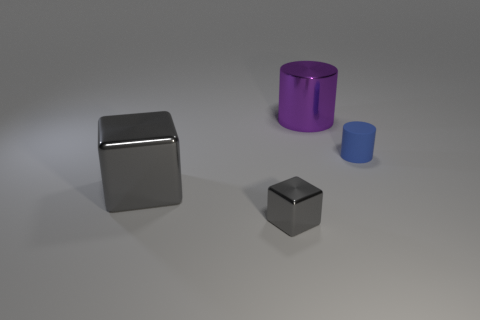There is a thing that is both behind the large gray metal block and to the left of the small blue rubber object; what is it made of?
Keep it short and to the point. Metal. Are there fewer blue rubber things on the left side of the small gray metal object than metallic cylinders that are in front of the tiny blue rubber cylinder?
Provide a succinct answer. No. What number of other objects are the same size as the blue cylinder?
Offer a terse response. 1. There is a big shiny object in front of the large metallic thing that is to the right of the tiny metallic object that is on the left side of the big purple object; what is its shape?
Your answer should be very brief. Cube. How many gray things are matte things or big balls?
Your response must be concise. 0. There is a large purple cylinder that is behind the tiny blue thing; what number of shiny things are on the left side of it?
Your answer should be compact. 2. Is there any other thing that is the same color as the large cube?
Make the answer very short. Yes. What shape is the purple thing that is made of the same material as the big cube?
Your answer should be very brief. Cylinder. Do the tiny metal object and the shiny cylinder have the same color?
Keep it short and to the point. No. Do the tiny object that is in front of the tiny cylinder and the cylinder that is right of the big purple shiny cylinder have the same material?
Make the answer very short. No. 